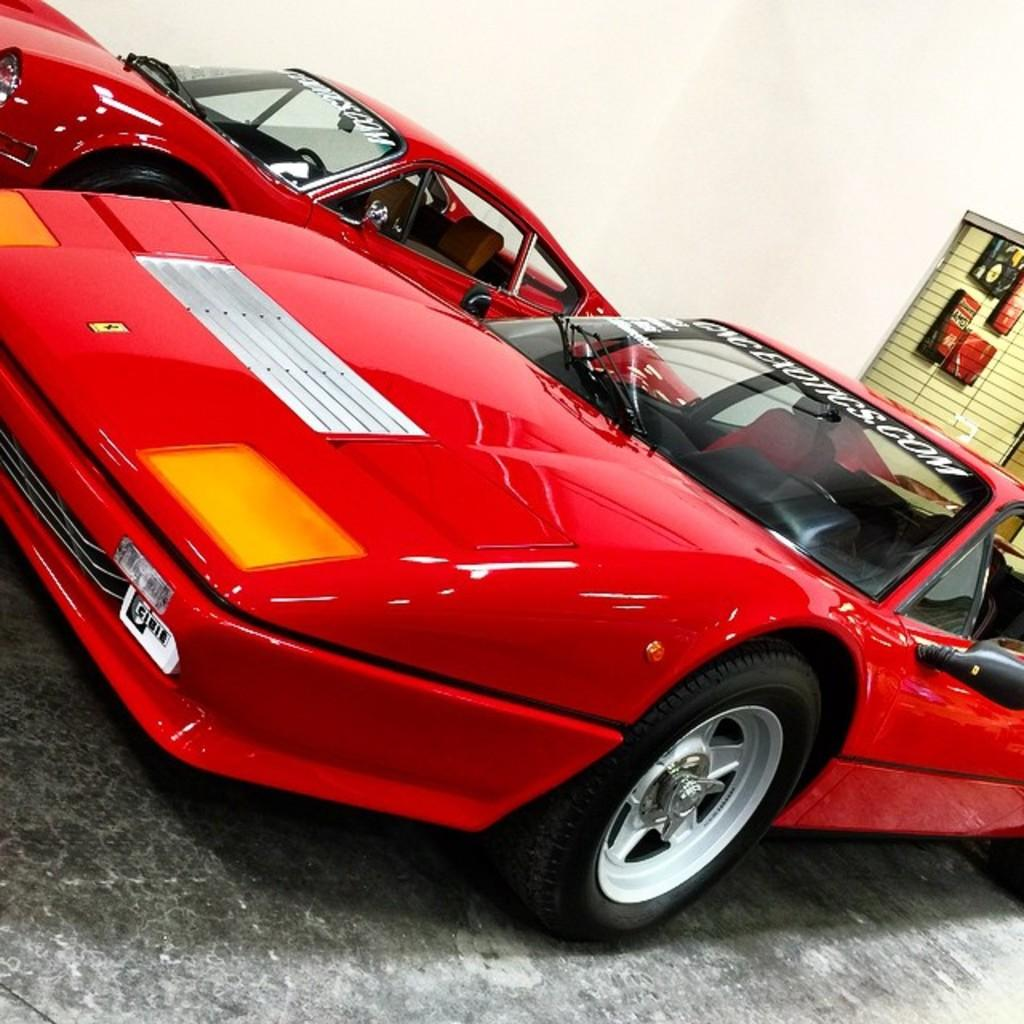What type of vehicles are in the image? There are cars in the image. What color are the cars? The cars are red. What can be seen in the background of the image? There is a wall and a window in the background of the image. How much debt do the cars have in the image? There is no information about debt in the image, as it features cars and a background. What type of trail can be seen in the image? There is no trail present in the image; it features cars and a background with a wall and a window. 